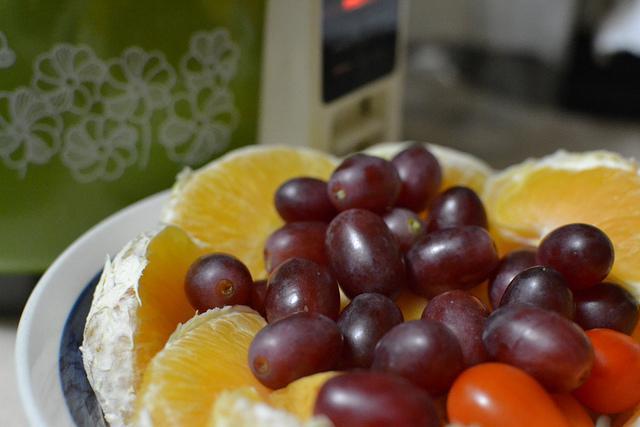How many oranges are there?
Give a very brief answer. 5. How many giraffes are in the photo?
Give a very brief answer. 0. 